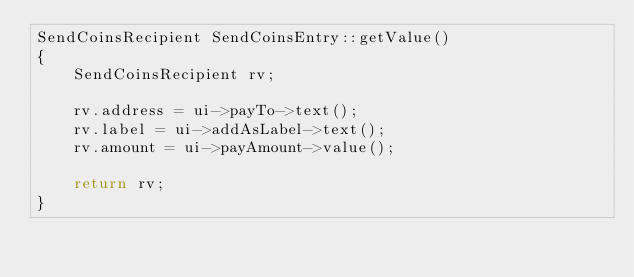Convert code to text. <code><loc_0><loc_0><loc_500><loc_500><_C++_>SendCoinsRecipient SendCoinsEntry::getValue()
{
    SendCoinsRecipient rv;

    rv.address = ui->payTo->text();
    rv.label = ui->addAsLabel->text();
    rv.amount = ui->payAmount->value();

    return rv;
}
</code> 